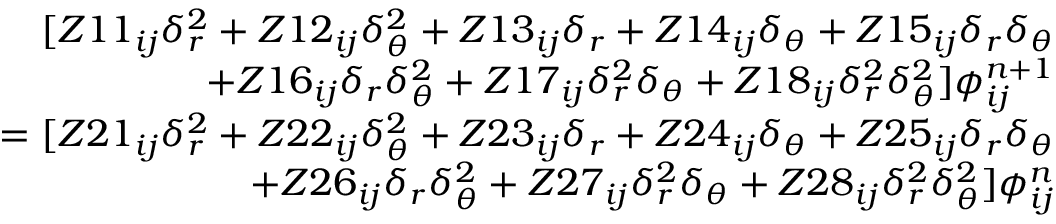<formula> <loc_0><loc_0><loc_500><loc_500>\begin{array} { r } { [ Z 1 1 _ { i j } \delta _ { r } ^ { 2 } + Z 1 2 _ { i j } \delta _ { \theta } ^ { 2 } + Z 1 3 _ { i j } \delta _ { r } + Z 1 4 _ { i j } \delta _ { \theta } + Z 1 5 _ { i j } \delta _ { r } \delta _ { \theta } } \\ { + Z 1 6 _ { i j } \delta _ { r } \delta _ { \theta } ^ { 2 } + Z 1 7 _ { i j } \delta _ { r } ^ { 2 } \delta _ { \theta } + Z 1 8 _ { i j } \delta _ { r } ^ { 2 } \delta _ { \theta } ^ { 2 } ] \phi _ { i j } ^ { n + 1 } } \\ { = [ Z 2 1 _ { i j } \delta _ { r } ^ { 2 } + Z 2 2 _ { i j } \delta _ { \theta } ^ { 2 } + Z 2 3 _ { i j } \delta _ { r } + Z 2 4 _ { i j } \delta _ { \theta } + Z 2 5 _ { i j } \delta _ { r } \delta _ { \theta } } \\ { + Z 2 6 _ { i j } \delta _ { r } \delta _ { \theta } ^ { 2 } + Z 2 7 _ { i j } \delta _ { r } ^ { 2 } \delta _ { \theta } + Z 2 8 _ { i j } \delta _ { r } ^ { 2 } \delta _ { \theta } ^ { 2 } ] \phi _ { i j } ^ { n } } \end{array}</formula> 